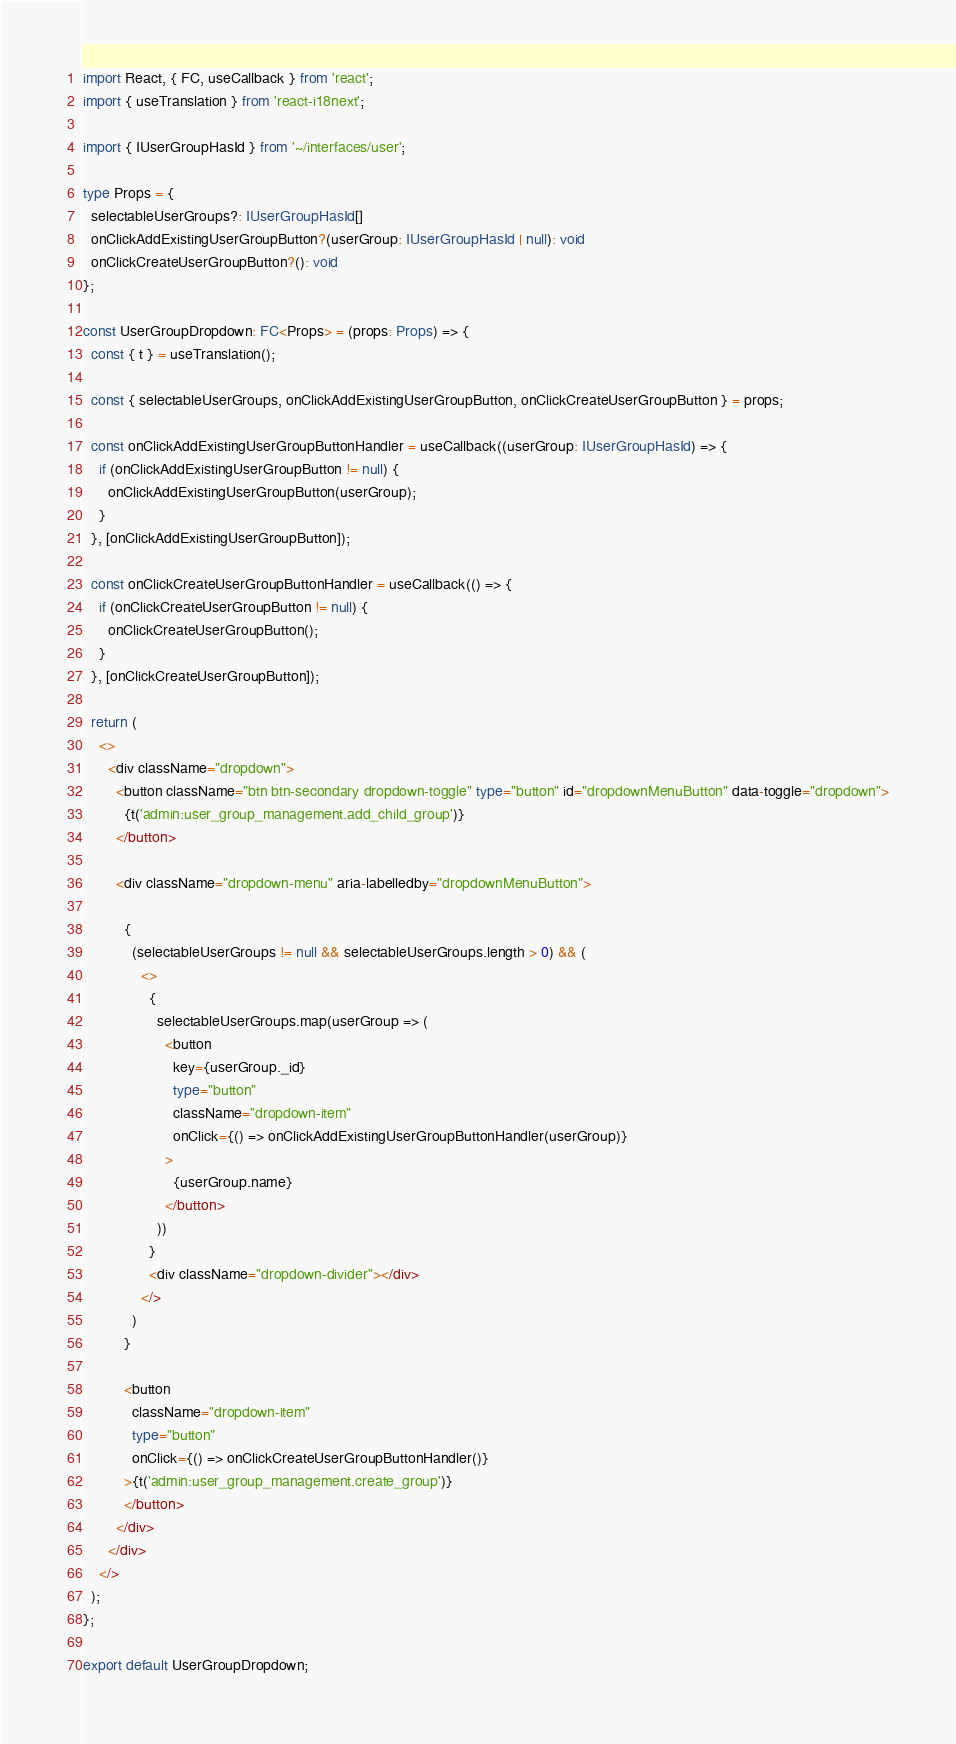Convert code to text. <code><loc_0><loc_0><loc_500><loc_500><_TypeScript_>import React, { FC, useCallback } from 'react';
import { useTranslation } from 'react-i18next';

import { IUserGroupHasId } from '~/interfaces/user';

type Props = {
  selectableUserGroups?: IUserGroupHasId[]
  onClickAddExistingUserGroupButton?(userGroup: IUserGroupHasId | null): void
  onClickCreateUserGroupButton?(): void
};

const UserGroupDropdown: FC<Props> = (props: Props) => {
  const { t } = useTranslation();

  const { selectableUserGroups, onClickAddExistingUserGroupButton, onClickCreateUserGroupButton } = props;

  const onClickAddExistingUserGroupButtonHandler = useCallback((userGroup: IUserGroupHasId) => {
    if (onClickAddExistingUserGroupButton != null) {
      onClickAddExistingUserGroupButton(userGroup);
    }
  }, [onClickAddExistingUserGroupButton]);

  const onClickCreateUserGroupButtonHandler = useCallback(() => {
    if (onClickCreateUserGroupButton != null) {
      onClickCreateUserGroupButton();
    }
  }, [onClickCreateUserGroupButton]);

  return (
    <>
      <div className="dropdown">
        <button className="btn btn-secondary dropdown-toggle" type="button" id="dropdownMenuButton" data-toggle="dropdown">
          {t('admin:user_group_management.add_child_group')}
        </button>

        <div className="dropdown-menu" aria-labelledby="dropdownMenuButton">

          {
            (selectableUserGroups != null && selectableUserGroups.length > 0) && (
              <>
                {
                  selectableUserGroups.map(userGroup => (
                    <button
                      key={userGroup._id}
                      type="button"
                      className="dropdown-item"
                      onClick={() => onClickAddExistingUserGroupButtonHandler(userGroup)}
                    >
                      {userGroup.name}
                    </button>
                  ))
                }
                <div className="dropdown-divider"></div>
              </>
            )
          }

          <button
            className="dropdown-item"
            type="button"
            onClick={() => onClickCreateUserGroupButtonHandler()}
          >{t('admin:user_group_management.create_group')}
          </button>
        </div>
      </div>
    </>
  );
};

export default UserGroupDropdown;
</code> 